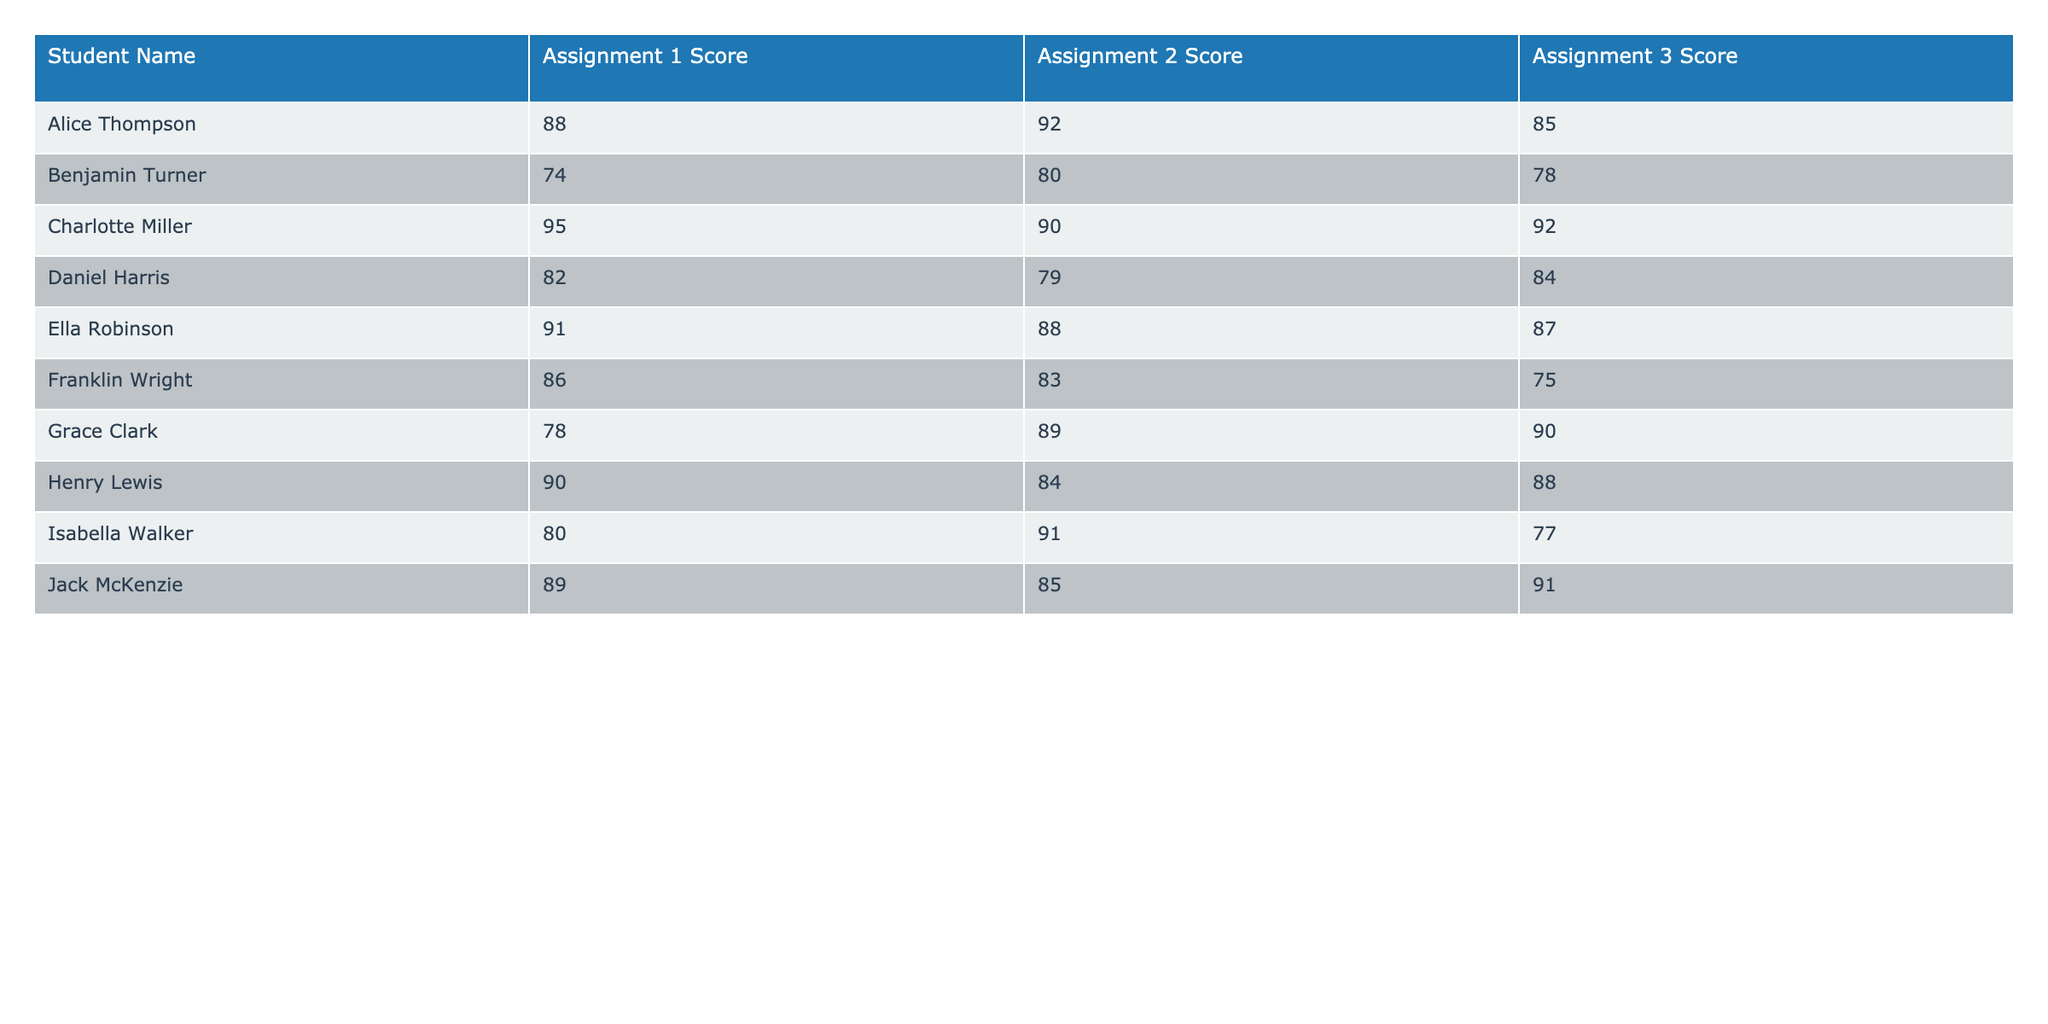What is the highest score achieved in Assignment 1? By looking at the scores for Assignment 1, we see that the maximum score is 95, which belongs to Charlotte Miller.
Answer: 95 Which student scored the lowest in Assignment 2? In the Assignment 2 scores, Benjamin Turner scored the lowest with a score of 80.
Answer: 80 What is the average score for Assignment 3? To calculate the average score for Assignment 3, we add all scores: (85 + 78 + 92 + 84 + 87 + 75 + 90 + 77 + 91) = 859. There are 9 students, so the average is 859 / 9 = approximately 95.44.
Answer: 95.44 Did any student score above 90 in all assignments? Upon checking, Charlotte Miller is the only student who has scores above 90 in both Assignment 1 (95) and Assignment 2 (90). However, she scored 92 in Assignment 3, making itYes, true.
Answer: Yes What is the difference between the highest and lowest scores in Assignment 1? The highest score in Assignment 1 is 95 (Charlotte Miller) and the lowest is 74 (Benjamin Turner). The difference is 95 - 74 = 21.
Answer: 21 Which student had the highest score in Assignment 2? The highest score in Assignment 2 is 92, achieved by Alice Thompson.
Answer: 92 What is the total score of Alice Thompson across all assignments? Alice Thompson's scores are: 88 (Assignment 1) + 92 (Assignment 2) + 85 (Assignment 3) = 265.
Answer: 265 Which student's average score across all assignments is higher than 85? First, we calculate the average for each student. For instance, Charlotte Miller's scores are (95 + 90 + 92) = 277, and her average is 277 / 3 = 92.33. The only students achieving higher than 85 are Charlotte Miller, Ella Robinson, and Jack McKenzie.
Answer: Charlotte Miller, Ella Robinson, Jack McKenzie What percentage of students scored below 80 in Assignment 3? Out of 9 students, 2 (Benjamin Turner and Franklin Wright) scored below 80, which is 2 / 9 ≈ 22.22%.
Answer: 22.22% Which assignment had the highest overall average score? To find which assignment had the highest average, we average each assignment's scores. Assignment 1: (88 + 74 + 95 + 82 + 91 + 86 + 78 + 90 + 89) = 86.67, Assignment 2: (92 + 80 + 90 + 79 + 88 + 83 + 89 + 91 + 85) = 85.56, Assignment 3: (85 + 78 + 92 + 84 + 87 + 75 + 90 + 77 + 91) = 85.56. Thus, Assignment 1 has the highest average score at 86.67.
Answer: Assignment 1 Who had the second highest score in Assignment 3? The second highest score in Assignment 3 is from Ella Robinson, who scored 87.
Answer: 87 